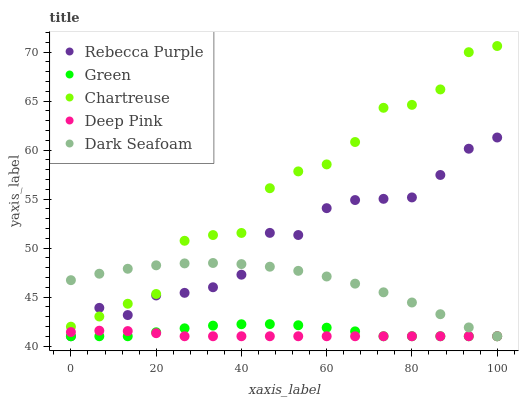Does Deep Pink have the minimum area under the curve?
Answer yes or no. Yes. Does Chartreuse have the maximum area under the curve?
Answer yes or no. Yes. Does Green have the minimum area under the curve?
Answer yes or no. No. Does Green have the maximum area under the curve?
Answer yes or no. No. Is Deep Pink the smoothest?
Answer yes or no. Yes. Is Chartreuse the roughest?
Answer yes or no. Yes. Is Green the smoothest?
Answer yes or no. No. Is Green the roughest?
Answer yes or no. No. Does Deep Pink have the lowest value?
Answer yes or no. Yes. Does Chartreuse have the highest value?
Answer yes or no. Yes. Does Green have the highest value?
Answer yes or no. No. Is Deep Pink less than Chartreuse?
Answer yes or no. Yes. Is Chartreuse greater than Green?
Answer yes or no. Yes. Does Deep Pink intersect Green?
Answer yes or no. Yes. Is Deep Pink less than Green?
Answer yes or no. No. Is Deep Pink greater than Green?
Answer yes or no. No. Does Deep Pink intersect Chartreuse?
Answer yes or no. No. 